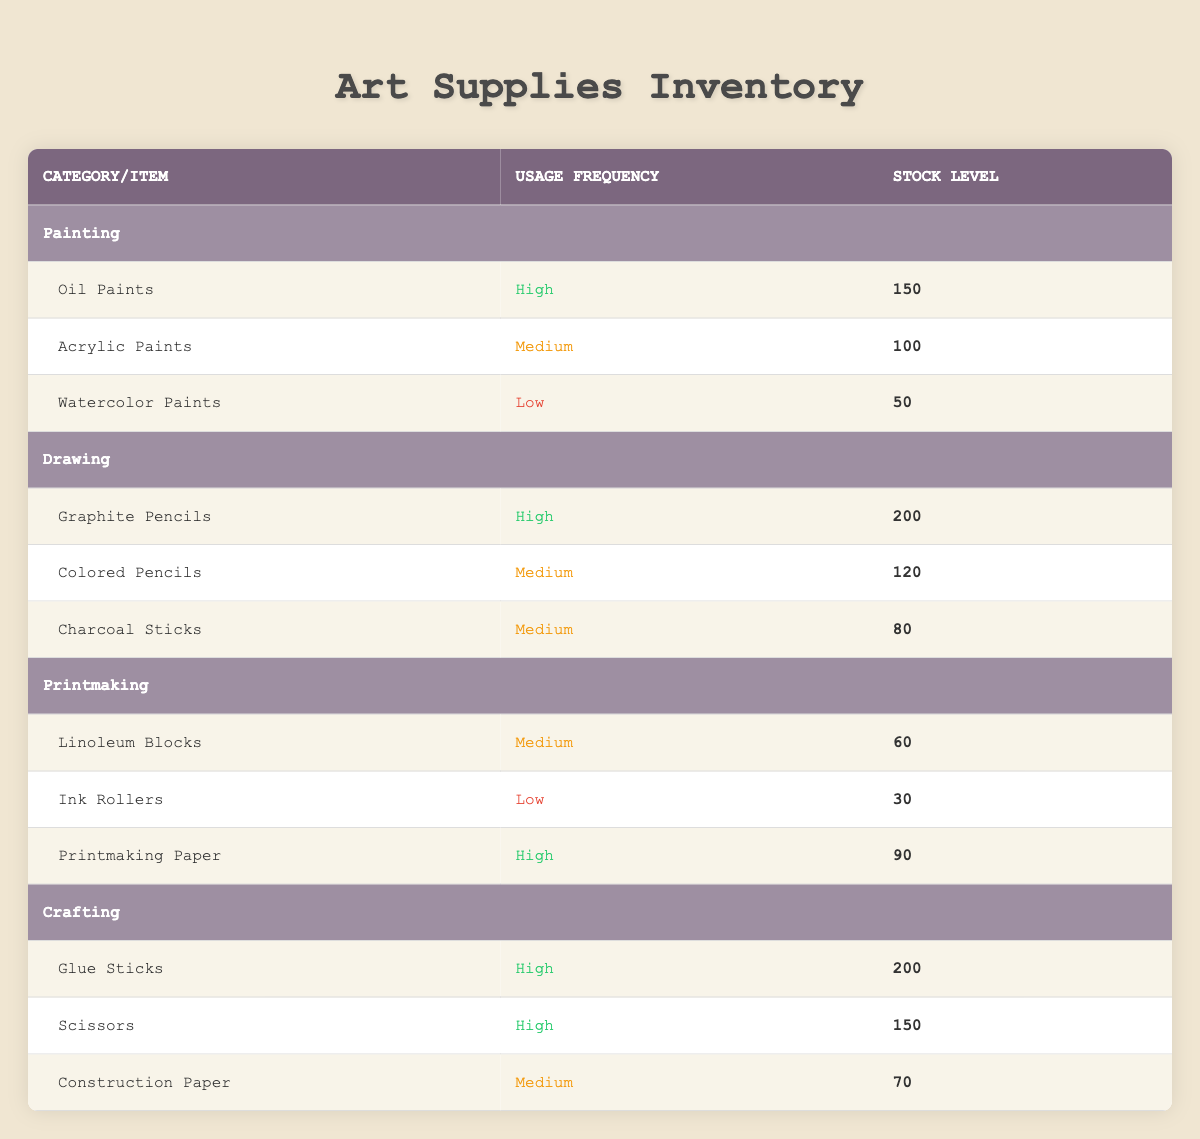What is the stock level of oil paints? The table lists oil paints under the Painting category. The corresponding stock level is provided directly in the table, which shows 150.
Answer: 150 How many items have high usage frequency? By examining the table, we can count the items categorized as having high usage frequency. There are four items: Oil Paints, Graphite Pencils, Glue Sticks, and Scissors.
Answer: 4 Which category has the least stock level? The lowest stock level can be found by comparing the stock levels across all categories. The Printmaking category has Ink Rollers with a stock level of 30, which is the lowest.
Answer: Printmaking What is the total stock level for crafting supplies? To find the total stock level for crafting supplies, we add up the stock levels of Glue Sticks (200), Scissors (150), and Construction Paper (70). The sum is 200 + 150 + 70 = 420.
Answer: 420 Does colored pencils have a low usage frequency? The table shows that colored pencils have a medium usage frequency, not low. Therefore, this statement is false.
Answer: No How many items are in the painting category with a medium or low usage frequency? In the Painting category, there are two items with medium or low usage frequency: Acrylic Paints (Medium) and Watercolor Paints (Low). Thus, we count two items.
Answer: 2 Is the stock level of printmaking paper greater than that of watercolor paints? Printmaking Paper has a stock level of 90, while Watercolor Paints have 50. Since 90 is greater than 50, this statement is true.
Answer: Yes What is the average stock level of items that have high usage frequency? We first identify the items with high usage frequency: Oil Paints (150), Graphite Pencils (200), Glue Sticks (200), and Scissors (150). The total stock for these items is 150 + 200 + 200 + 150 = 700. Then we divide by the number of items (4) to get the average: 700 / 4 = 175.
Answer: 175 